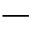Convert formula to latex. <formula><loc_0><loc_0><loc_500><loc_500>-</formula> 